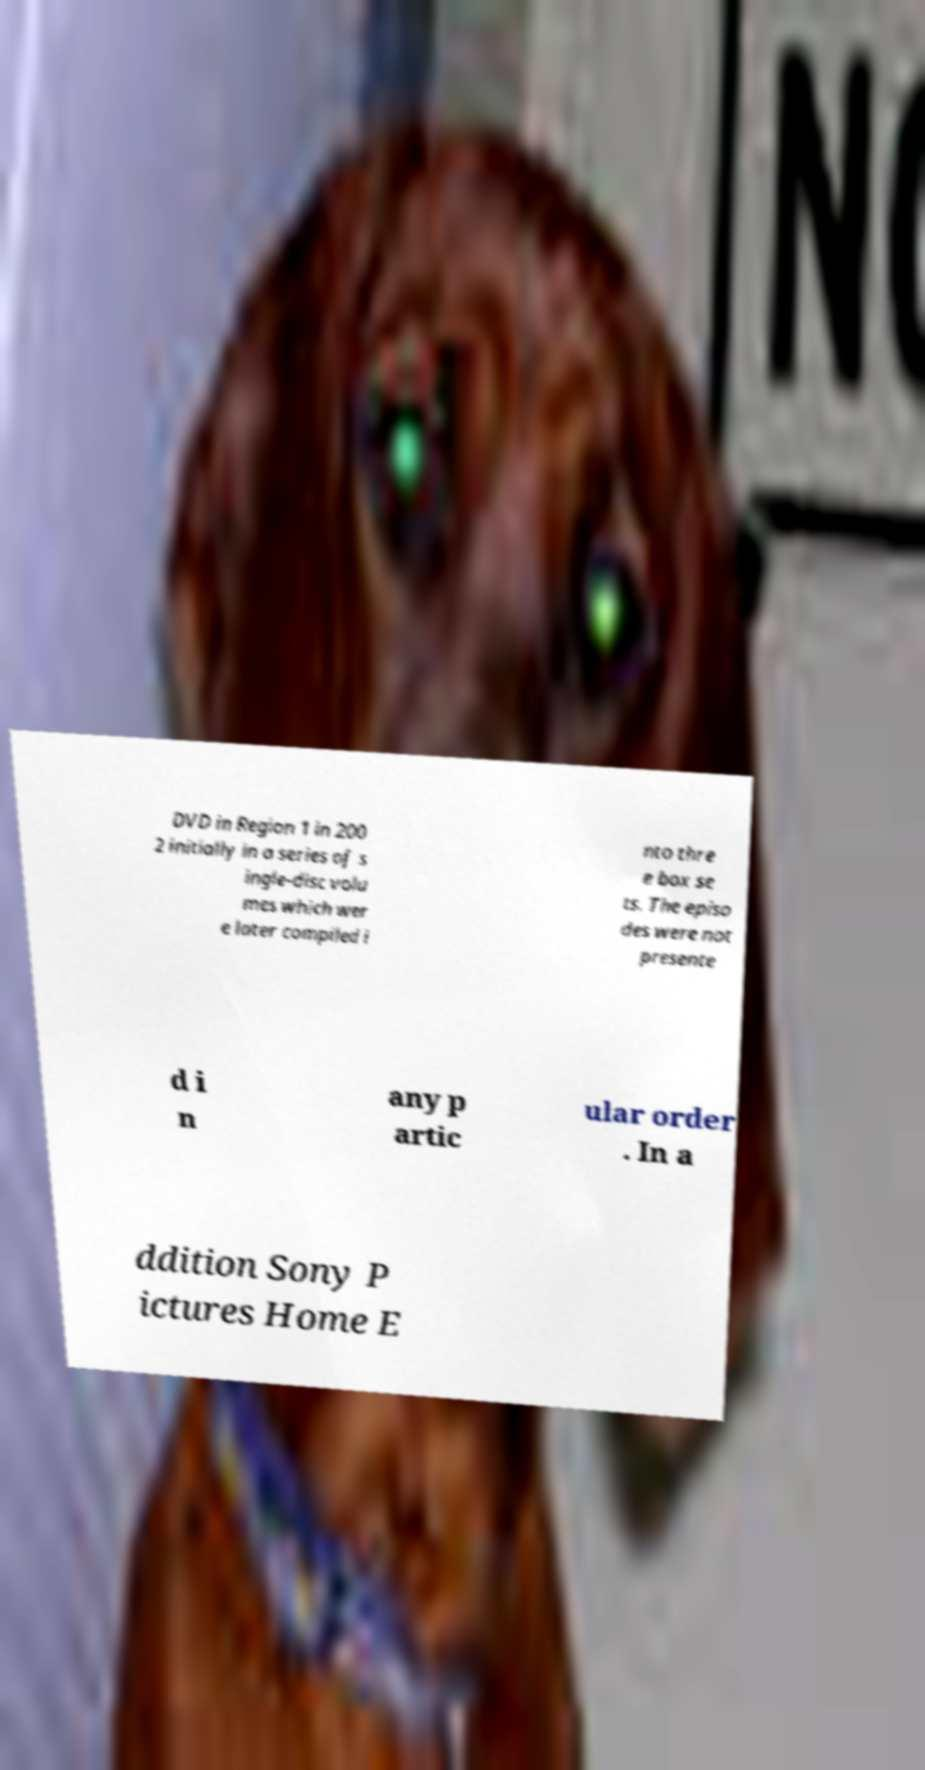Could you assist in decoding the text presented in this image and type it out clearly? DVD in Region 1 in 200 2 initially in a series of s ingle-disc volu mes which wer e later compiled i nto thre e box se ts. The episo des were not presente d i n any p artic ular order . In a ddition Sony P ictures Home E 